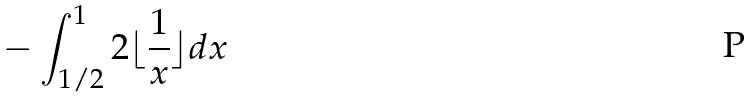<formula> <loc_0><loc_0><loc_500><loc_500>- \int _ { 1 / 2 } ^ { 1 } 2 \lfloor \frac { 1 } { x } \rfloor d x</formula> 